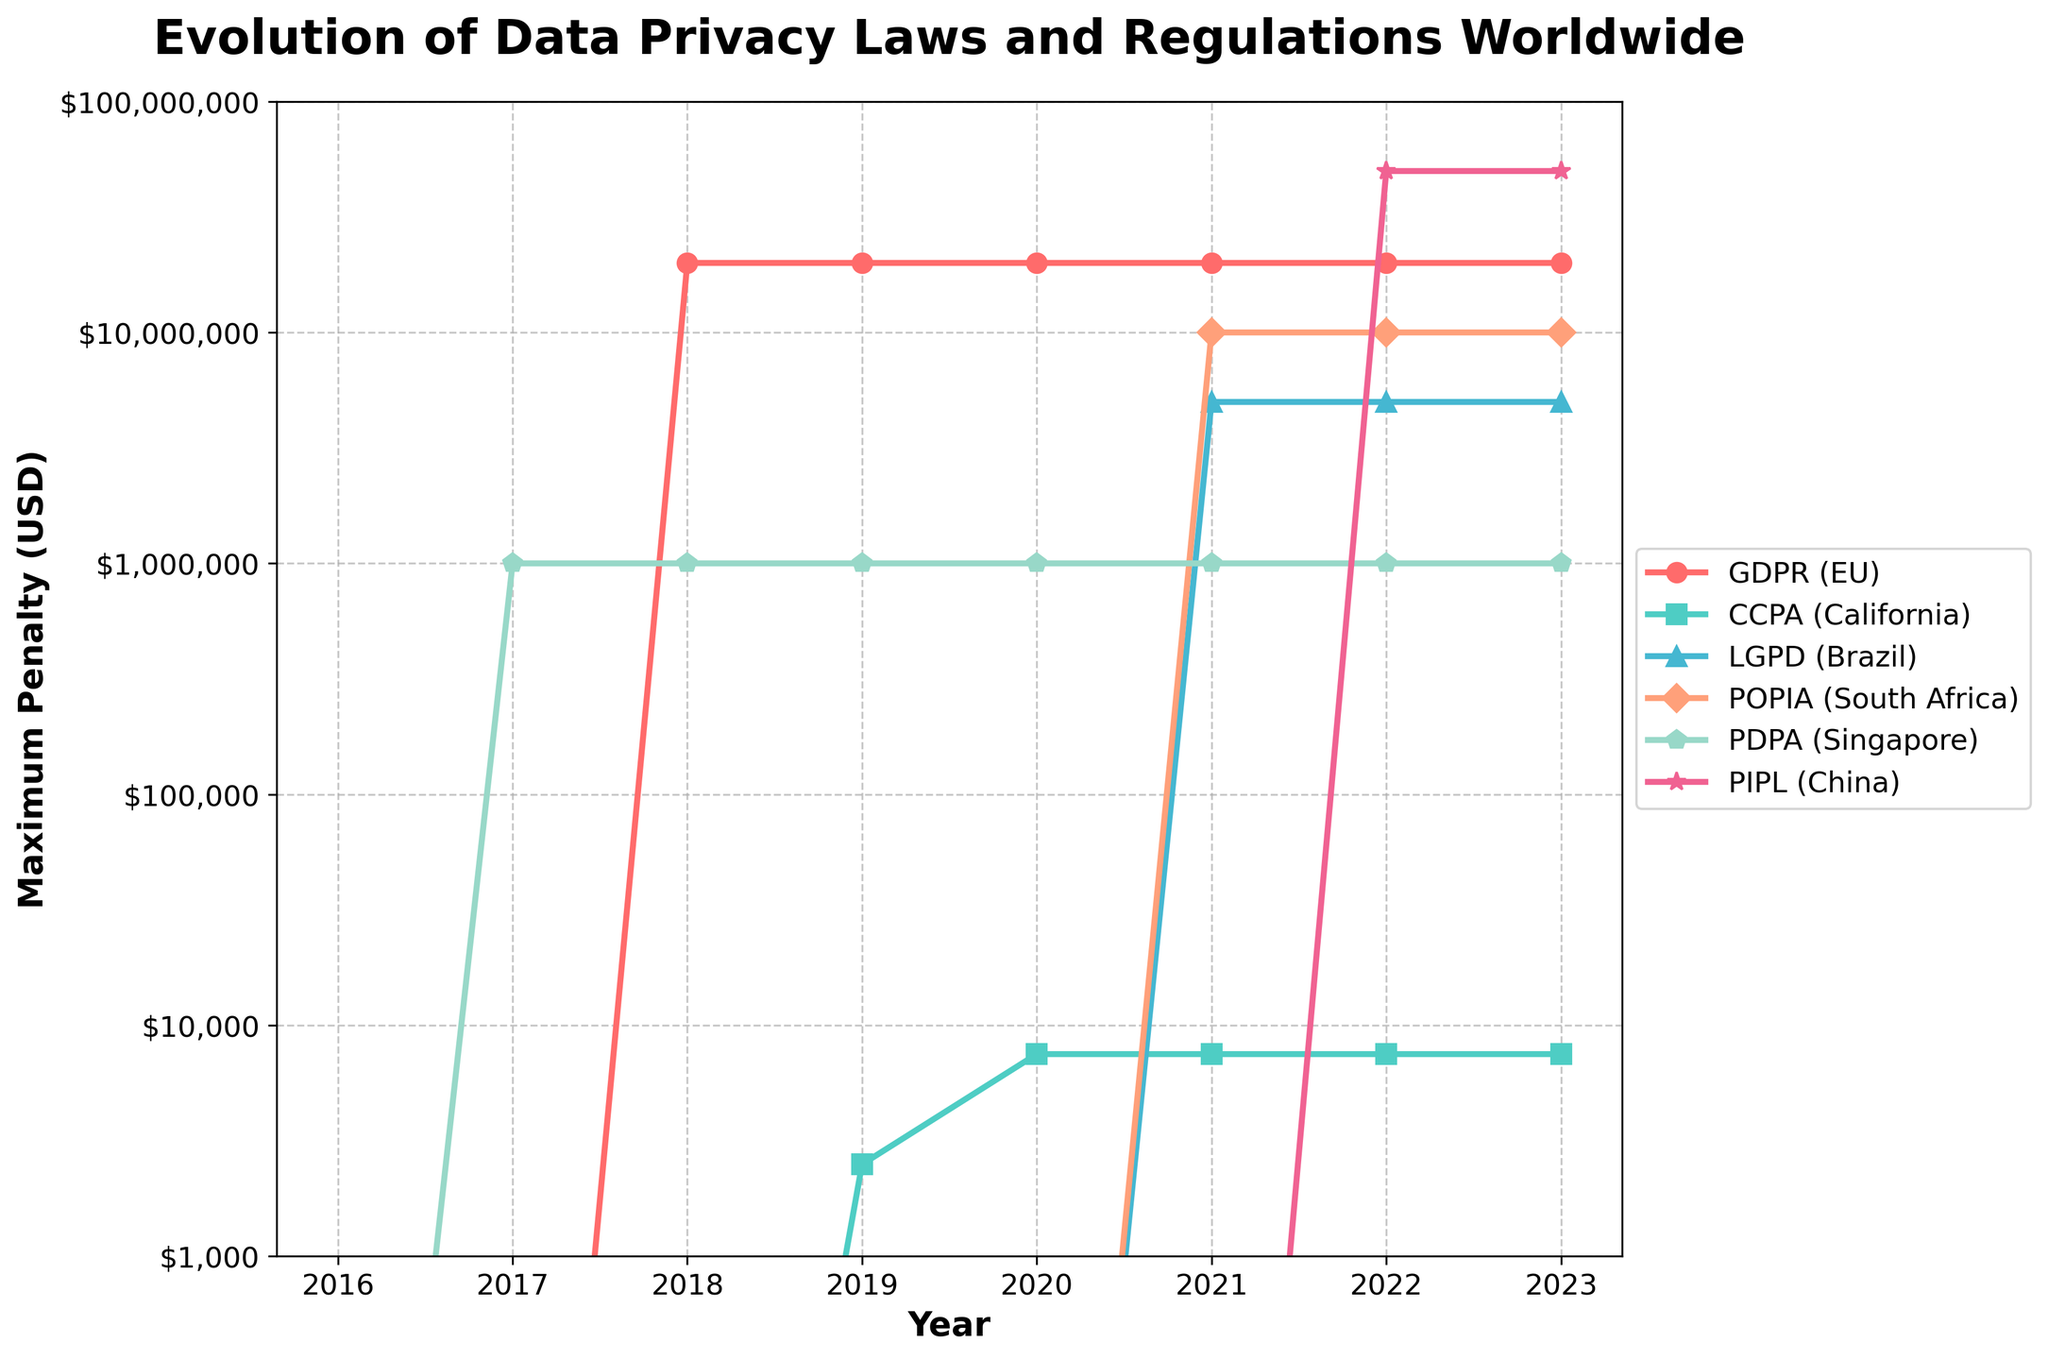What is the maximum penalty imposed by GDPR in 2018? To find the maximum penalty for GDPR in 2018, look at the data point for the year 2018 on the line corresponding to GDPR. The value is $20,000,000.
Answer: $20,000,000 Between 2019 and 2021, which data privacy law introduced the most significant increase in penalties? Compare the penalty increases between 2019 and 2021 for each data privacy law. GDPR remained the same, CCPA increased by $5000, LGPD increased by $5,000,000, POPIA increased by $10,000,000, and PDPA remained the same. POPIA saw the most significant increase of $10,000,000.
Answer: POPIA Which year saw the implementation of the maximum penalty for China’s PIPL? Observe the line corresponding to PIPL (China) and identify the year with the highest penalty. The maximum penalty of $50,000,000 is seen in 2022.
Answer: 2022 How many data privacy laws had their penalties unchanged between 2022 and 2023? Observe the lines between 2022 and 2023. GDPR (EU), CCPA (California), LGPD (Brazil), POPIA (South Africa), and PDPA (Singapore) all retained their penalties. Only PIPL (China) does not change between 2022 and 2023.
Answer: Five Which data privacy law had the lowest penalty in 2020, and what was it? Look at the data points for each law in 2020, identify the lowest value. CCPA (California) had the lowest penalty of $7,500.
Answer: CCPA, $7,500 What is the total penalty imposed by GDPR from 2018 to 2023? Sum the penalties for GDPR from 2018 to 2023. The penalties are $20,000,000 for each year from 2018 to 2023. $20,000,000 * 6 = $120,000,000.
Answer: $120,000,000 Between 2021 and 2022, which data privacy law in South Africa saw a penalty increase? Identify the penalty trend for POPIA (South Africa) between 2021 and 2022. The penalty increased from $10,000,000 to $10,000,000 (unchanged). Check other laws for changes. Only POPIA changed within South Africa.
Answer: None 